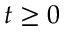<formula> <loc_0><loc_0><loc_500><loc_500>t \geq 0</formula> 